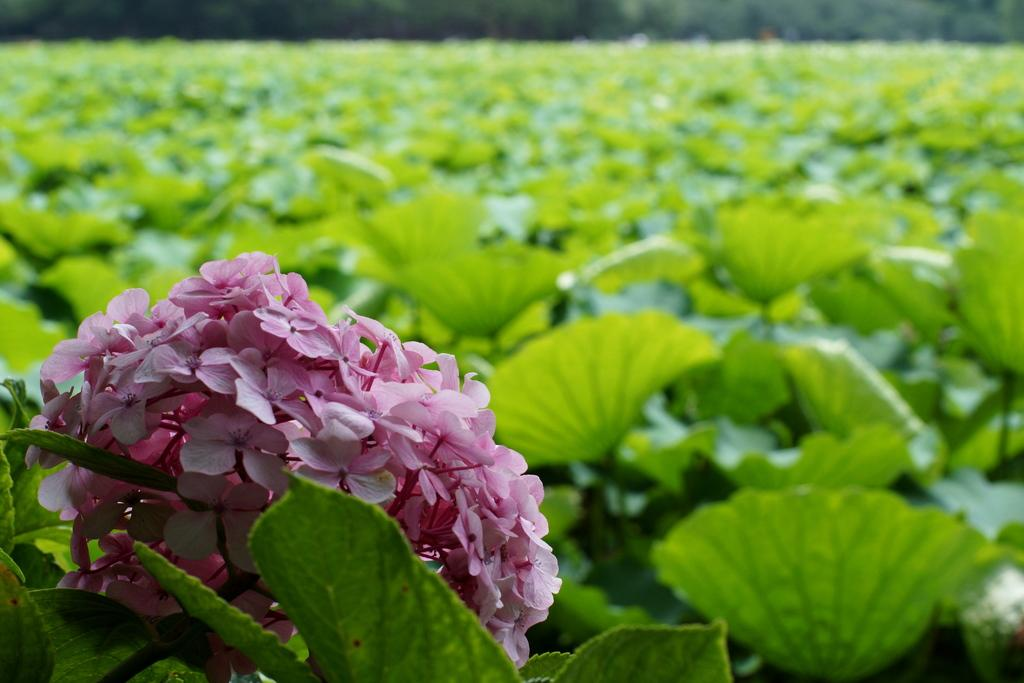What type of flowers are in the image? There is a bunch of pink flowers in the image. What else can be seen in the image besides the flowers? There are plants visible behind the flowers. What is visible in the background of the image? There are blurred trees visible in the background. What type of shame can be seen on the faces of the people in the image? There are no people present in the image, so it is not possible to determine if they are experiencing any shame. 